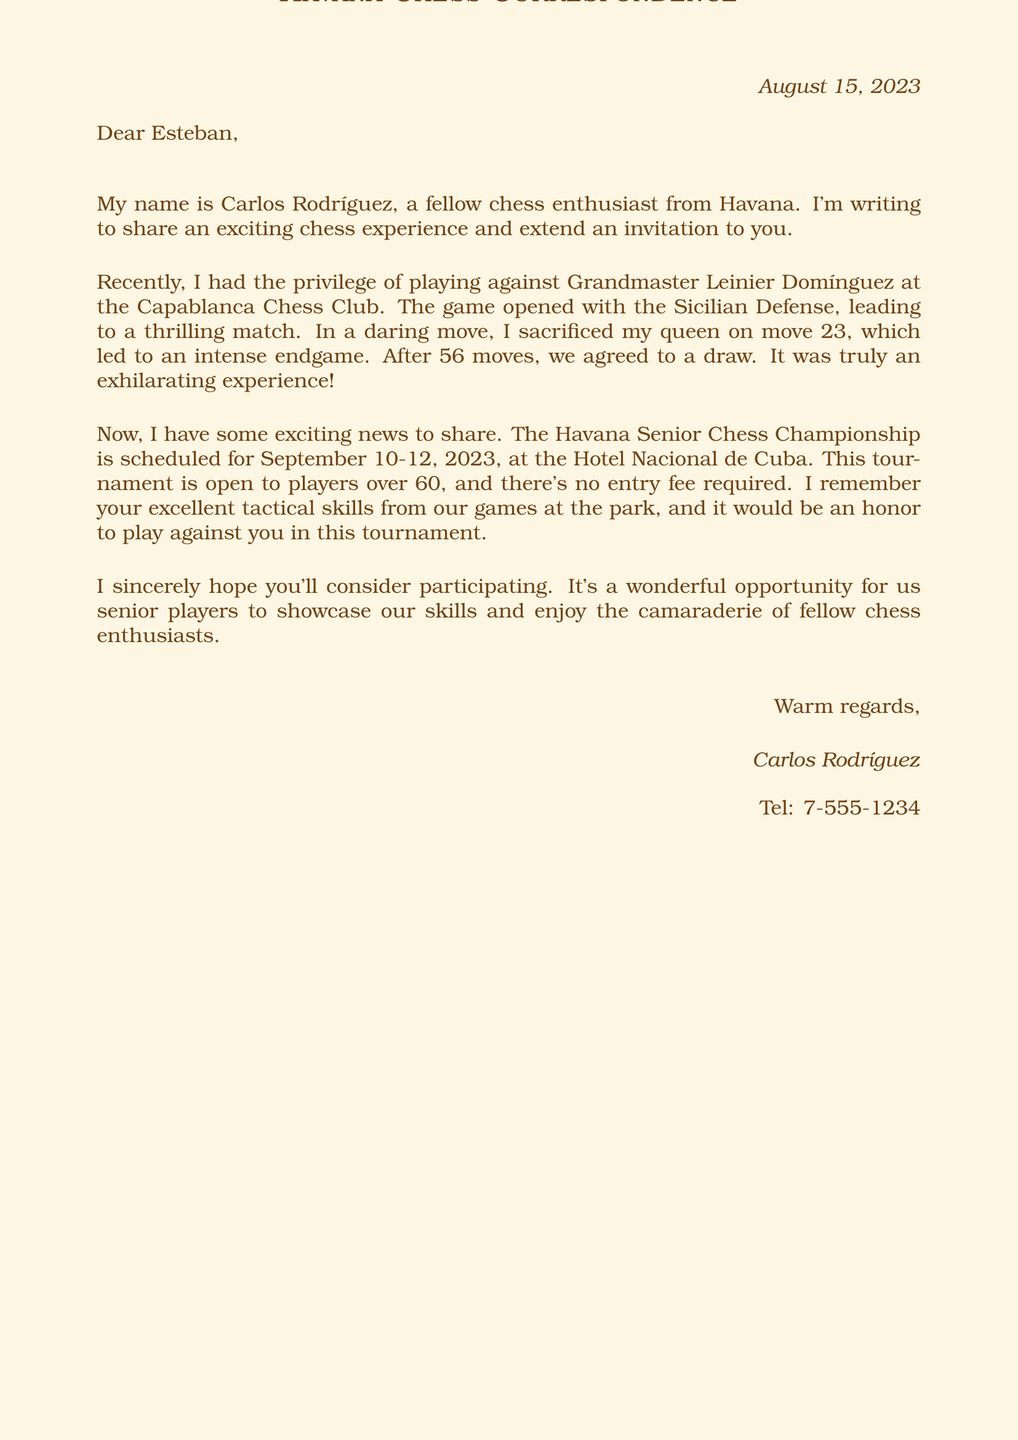What is the date of the letter? The date of the letter is clearly stated in the header of the document.
Answer: August 15, 2023 Who is the writer of the letter? The writer introduces himself in the opening paragraph of the letter.
Answer: Carlos Rodríguez What game did the writer play? The writer describes a specific chess game in detail including the opponent and location.
Answer: Against Grandmaster Leinier Domínguez What chess opening was used in the game? The specific opening of the game is mentioned in the game description section.
Answer: Sicilian Defense What was the outcome of the game? The final result of the game is noted towards the end of the game description.
Answer: Draw after 56 moves What is the name of the tournament mentioned? The letter includes information about an upcoming chess tournament.
Answer: Havana Senior Chess Championship When will the tournament take place? The date for the tournament is provided in the tournament invitation section.
Answer: September 10-12, 2023 What is the venue for the tournament? The location of the tournament is specified in the invitation details.
Answer: Hotel Nacional de Cuba Who is invited to the tournament? The letter outlines the eligibility criteria for participants in the tournament.
Answer: Players over 60 